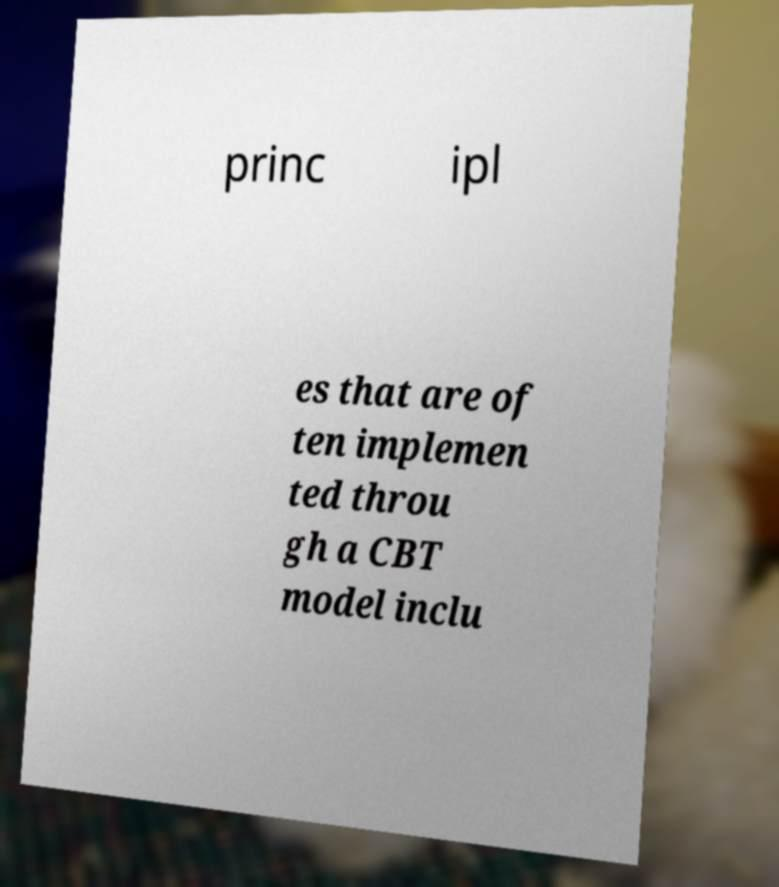Please read and relay the text visible in this image. What does it say? princ ipl es that are of ten implemen ted throu gh a CBT model inclu 